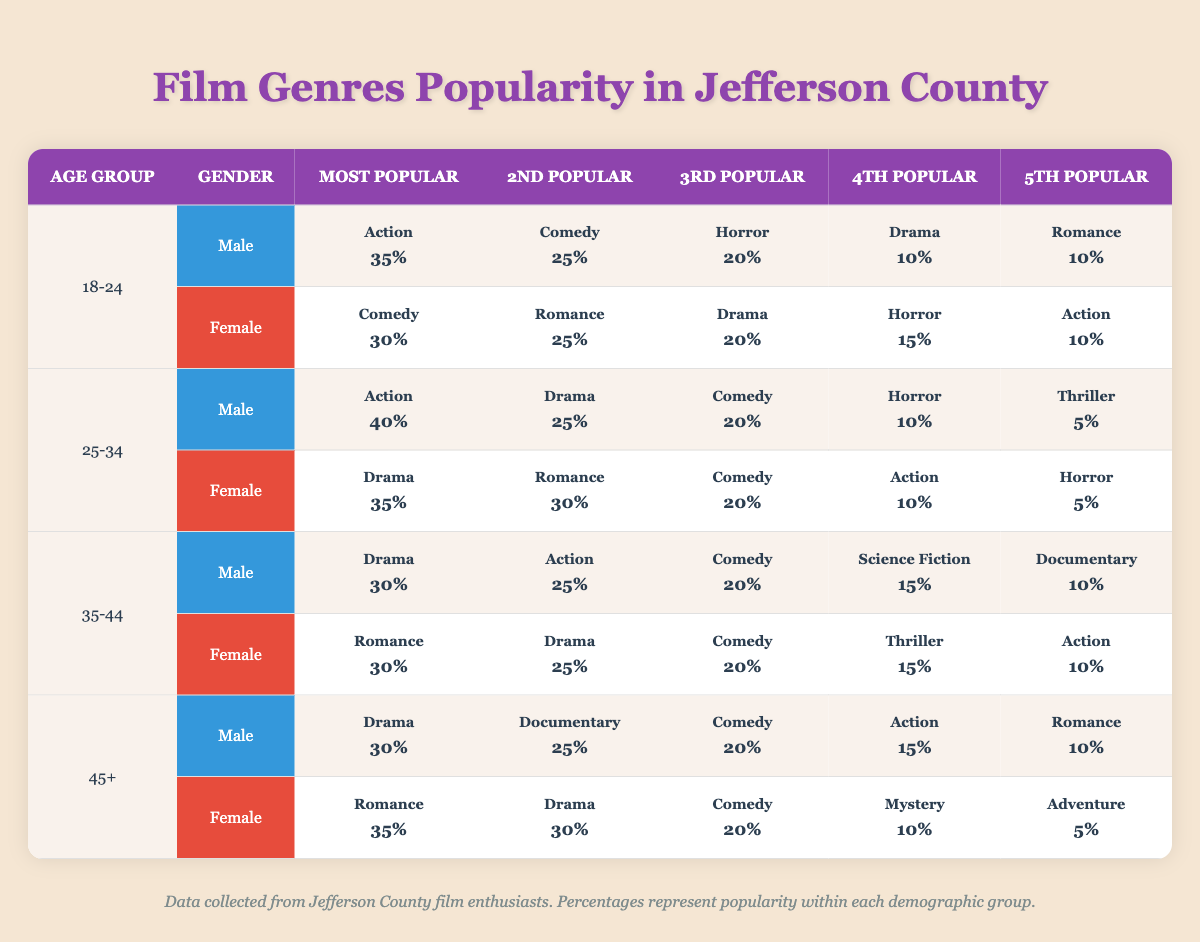What is the most popular genre for males aged 18-24? From the table, look under the row for the age group 18-24 and the column for male. The most popular genre listed is Action at 35%.
Answer: Action Which genre is the second most popular among females in the 25-34 age group? Locate the row for 25-34, then find the female column. The second most popular genre is Romance at 30%.
Answer: Romance What percentage of males aged 35-44 prefer Science Fiction? Refer to the row for the age group 35-44 and male column. Science Fiction has a popularity percentage of 15%.
Answer: 15% Is Comedy more popular than Drama among females aged 45 and older? Check the row for females 45+, Drama has 30% and Comedy has 20%. Since 30% is greater than 20%, the answer is no.
Answer: No What is the total percentage of popular genres for males in the 25-34 age group? Total the percentages for all genres under the males aged 25-34: (40 + 25 + 20 + 10 + 5) = 100%.
Answer: 100% Which gender in the 35-44 age group has a higher popularity for the genre Action? Compare the percentages for Action in the rows for both genders in the 35-44 age group: Males have 25% and Females have 10%. Males have a higher percentage.
Answer: Males What is the difference in popularity between the most popular genre among 18-24-year-old males and females? For males, the most popular genre is Action at 35%; for females, it is Comedy at 30%. The difference is 35% - 30% = 5%.
Answer: 5% How does the popularity of Horror compare between the two genders in the 18-24 age group? The row for males shows Horror at 20%, while the row for females shows Horror at 15%. Males have a higher preference for Horror by 5%.
Answer: Males by 5% What genre do females aged 45 and older prefer the most? Reference the row for females in the 45+ age group. The most popular genre is Romance at 35%.
Answer: Romance 